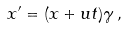<formula> <loc_0><loc_0><loc_500><loc_500>x ^ { \prime } = ( x + u t ) \gamma \, ,</formula> 